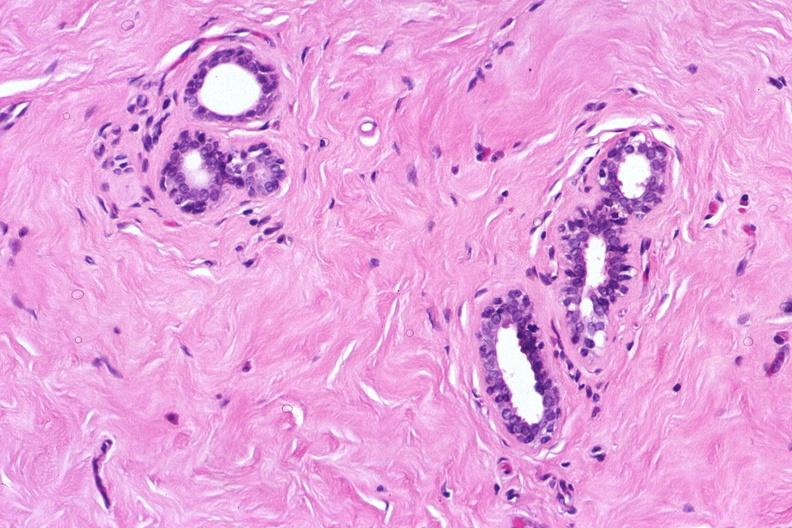s female reproductive present?
Answer the question using a single word or phrase. Yes 